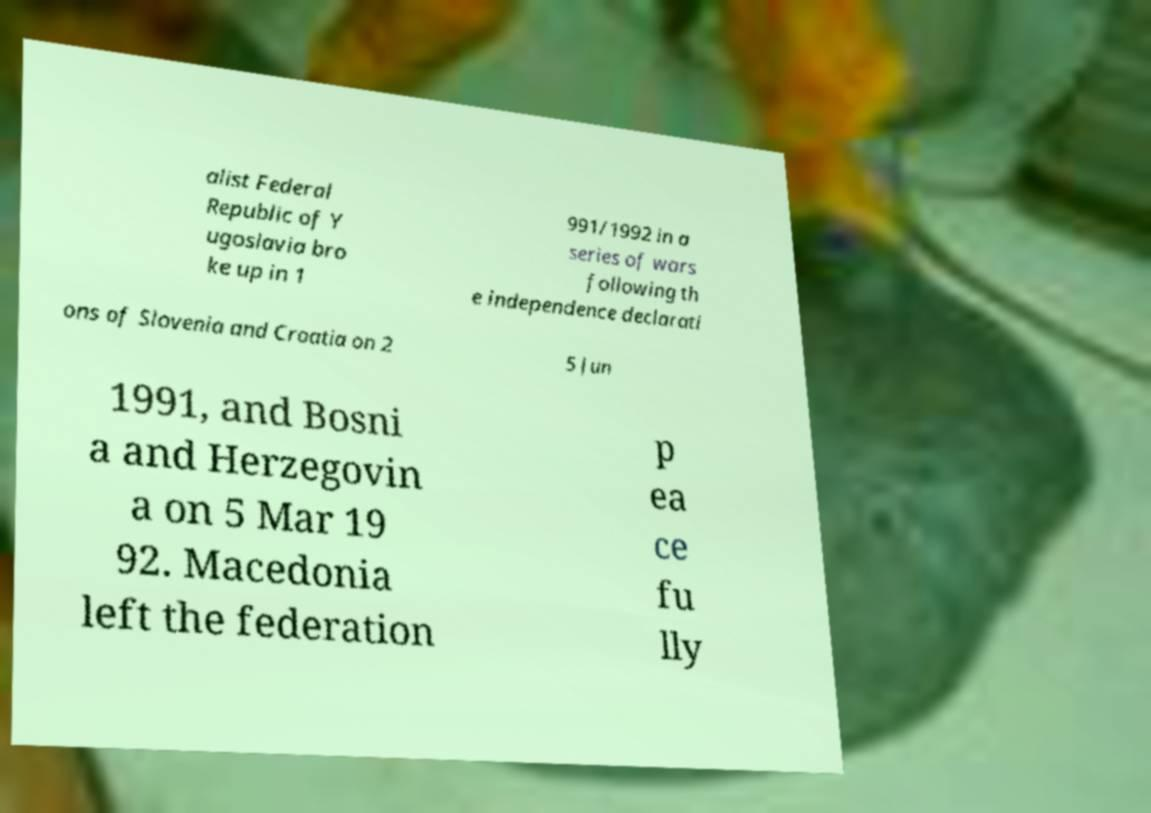Please identify and transcribe the text found in this image. alist Federal Republic of Y ugoslavia bro ke up in 1 991/1992 in a series of wars following th e independence declarati ons of Slovenia and Croatia on 2 5 Jun 1991, and Bosni a and Herzegovin a on 5 Mar 19 92. Macedonia left the federation p ea ce fu lly 